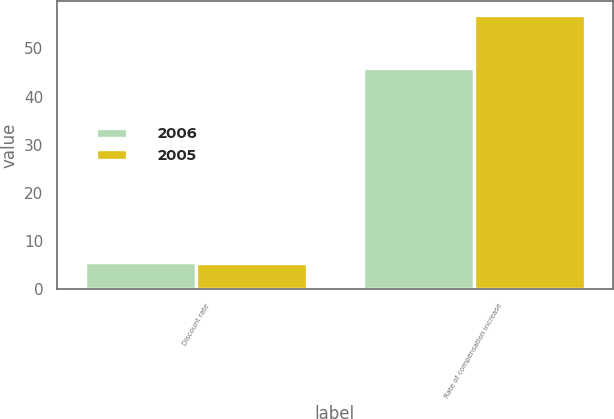Convert chart. <chart><loc_0><loc_0><loc_500><loc_500><stacked_bar_chart><ecel><fcel>Discount rate<fcel>Rate of compensation increase<nl><fcel>2006<fcel>5.75<fcel>46<nl><fcel>2005<fcel>5.5<fcel>57<nl></chart> 